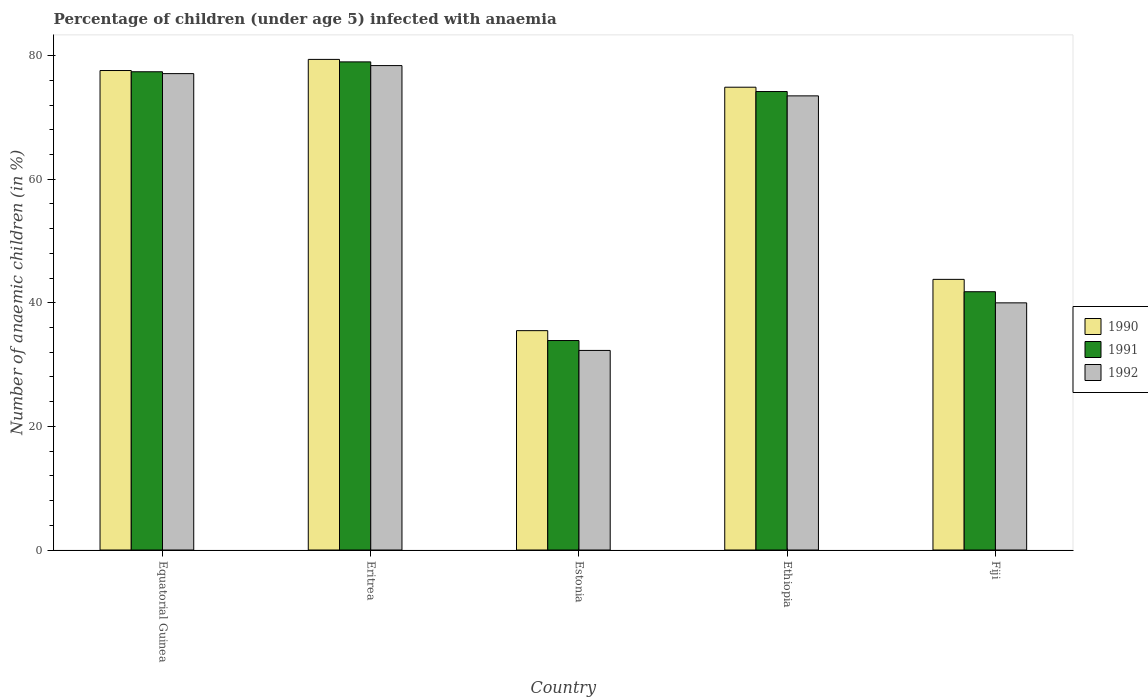How many different coloured bars are there?
Keep it short and to the point. 3. How many groups of bars are there?
Your answer should be compact. 5. How many bars are there on the 2nd tick from the left?
Give a very brief answer. 3. What is the label of the 2nd group of bars from the left?
Give a very brief answer. Eritrea. In how many cases, is the number of bars for a given country not equal to the number of legend labels?
Your answer should be compact. 0. What is the percentage of children infected with anaemia in in 1992 in Ethiopia?
Give a very brief answer. 73.5. Across all countries, what is the maximum percentage of children infected with anaemia in in 1991?
Offer a terse response. 79. Across all countries, what is the minimum percentage of children infected with anaemia in in 1991?
Your response must be concise. 33.9. In which country was the percentage of children infected with anaemia in in 1992 maximum?
Provide a succinct answer. Eritrea. In which country was the percentage of children infected with anaemia in in 1991 minimum?
Give a very brief answer. Estonia. What is the total percentage of children infected with anaemia in in 1990 in the graph?
Make the answer very short. 311.2. What is the difference between the percentage of children infected with anaemia in in 1991 in Equatorial Guinea and that in Ethiopia?
Provide a succinct answer. 3.2. What is the difference between the percentage of children infected with anaemia in in 1990 in Equatorial Guinea and the percentage of children infected with anaemia in in 1992 in Ethiopia?
Offer a terse response. 4.1. What is the average percentage of children infected with anaemia in in 1992 per country?
Ensure brevity in your answer.  60.26. What is the difference between the percentage of children infected with anaemia in of/in 1991 and percentage of children infected with anaemia in of/in 1990 in Fiji?
Provide a short and direct response. -2. In how many countries, is the percentage of children infected with anaemia in in 1991 greater than 60 %?
Provide a succinct answer. 3. What is the ratio of the percentage of children infected with anaemia in in 1990 in Equatorial Guinea to that in Estonia?
Your answer should be compact. 2.19. What is the difference between the highest and the second highest percentage of children infected with anaemia in in 1991?
Your response must be concise. -3.2. What is the difference between the highest and the lowest percentage of children infected with anaemia in in 1991?
Provide a short and direct response. 45.1. In how many countries, is the percentage of children infected with anaemia in in 1990 greater than the average percentage of children infected with anaemia in in 1990 taken over all countries?
Your response must be concise. 3. What does the 2nd bar from the left in Fiji represents?
Your answer should be compact. 1991. Is it the case that in every country, the sum of the percentage of children infected with anaemia in in 1990 and percentage of children infected with anaemia in in 1991 is greater than the percentage of children infected with anaemia in in 1992?
Your answer should be compact. Yes. How many bars are there?
Your answer should be compact. 15. What is the difference between two consecutive major ticks on the Y-axis?
Offer a terse response. 20. Does the graph contain grids?
Offer a terse response. No. How are the legend labels stacked?
Offer a very short reply. Vertical. What is the title of the graph?
Make the answer very short. Percentage of children (under age 5) infected with anaemia. Does "1970" appear as one of the legend labels in the graph?
Offer a terse response. No. What is the label or title of the X-axis?
Give a very brief answer. Country. What is the label or title of the Y-axis?
Keep it short and to the point. Number of anaemic children (in %). What is the Number of anaemic children (in %) of 1990 in Equatorial Guinea?
Your answer should be compact. 77.6. What is the Number of anaemic children (in %) in 1991 in Equatorial Guinea?
Ensure brevity in your answer.  77.4. What is the Number of anaemic children (in %) in 1992 in Equatorial Guinea?
Make the answer very short. 77.1. What is the Number of anaemic children (in %) of 1990 in Eritrea?
Offer a very short reply. 79.4. What is the Number of anaemic children (in %) of 1991 in Eritrea?
Your answer should be very brief. 79. What is the Number of anaemic children (in %) in 1992 in Eritrea?
Ensure brevity in your answer.  78.4. What is the Number of anaemic children (in %) of 1990 in Estonia?
Provide a succinct answer. 35.5. What is the Number of anaemic children (in %) of 1991 in Estonia?
Keep it short and to the point. 33.9. What is the Number of anaemic children (in %) of 1992 in Estonia?
Your response must be concise. 32.3. What is the Number of anaemic children (in %) in 1990 in Ethiopia?
Make the answer very short. 74.9. What is the Number of anaemic children (in %) in 1991 in Ethiopia?
Provide a short and direct response. 74.2. What is the Number of anaemic children (in %) of 1992 in Ethiopia?
Ensure brevity in your answer.  73.5. What is the Number of anaemic children (in %) of 1990 in Fiji?
Offer a terse response. 43.8. What is the Number of anaemic children (in %) in 1991 in Fiji?
Your answer should be very brief. 41.8. What is the Number of anaemic children (in %) of 1992 in Fiji?
Ensure brevity in your answer.  40. Across all countries, what is the maximum Number of anaemic children (in %) of 1990?
Your answer should be compact. 79.4. Across all countries, what is the maximum Number of anaemic children (in %) of 1991?
Provide a succinct answer. 79. Across all countries, what is the maximum Number of anaemic children (in %) of 1992?
Offer a terse response. 78.4. Across all countries, what is the minimum Number of anaemic children (in %) of 1990?
Make the answer very short. 35.5. Across all countries, what is the minimum Number of anaemic children (in %) in 1991?
Give a very brief answer. 33.9. Across all countries, what is the minimum Number of anaemic children (in %) in 1992?
Your response must be concise. 32.3. What is the total Number of anaemic children (in %) in 1990 in the graph?
Your answer should be very brief. 311.2. What is the total Number of anaemic children (in %) in 1991 in the graph?
Give a very brief answer. 306.3. What is the total Number of anaemic children (in %) of 1992 in the graph?
Your answer should be very brief. 301.3. What is the difference between the Number of anaemic children (in %) of 1990 in Equatorial Guinea and that in Eritrea?
Make the answer very short. -1.8. What is the difference between the Number of anaemic children (in %) of 1992 in Equatorial Guinea and that in Eritrea?
Provide a short and direct response. -1.3. What is the difference between the Number of anaemic children (in %) of 1990 in Equatorial Guinea and that in Estonia?
Make the answer very short. 42.1. What is the difference between the Number of anaemic children (in %) in 1991 in Equatorial Guinea and that in Estonia?
Give a very brief answer. 43.5. What is the difference between the Number of anaemic children (in %) of 1992 in Equatorial Guinea and that in Estonia?
Your answer should be compact. 44.8. What is the difference between the Number of anaemic children (in %) of 1992 in Equatorial Guinea and that in Ethiopia?
Make the answer very short. 3.6. What is the difference between the Number of anaemic children (in %) of 1990 in Equatorial Guinea and that in Fiji?
Your response must be concise. 33.8. What is the difference between the Number of anaemic children (in %) of 1991 in Equatorial Guinea and that in Fiji?
Your answer should be very brief. 35.6. What is the difference between the Number of anaemic children (in %) in 1992 in Equatorial Guinea and that in Fiji?
Offer a very short reply. 37.1. What is the difference between the Number of anaemic children (in %) in 1990 in Eritrea and that in Estonia?
Offer a very short reply. 43.9. What is the difference between the Number of anaemic children (in %) of 1991 in Eritrea and that in Estonia?
Offer a terse response. 45.1. What is the difference between the Number of anaemic children (in %) of 1992 in Eritrea and that in Estonia?
Offer a terse response. 46.1. What is the difference between the Number of anaemic children (in %) in 1990 in Eritrea and that in Ethiopia?
Give a very brief answer. 4.5. What is the difference between the Number of anaemic children (in %) in 1992 in Eritrea and that in Ethiopia?
Give a very brief answer. 4.9. What is the difference between the Number of anaemic children (in %) of 1990 in Eritrea and that in Fiji?
Provide a short and direct response. 35.6. What is the difference between the Number of anaemic children (in %) of 1991 in Eritrea and that in Fiji?
Your answer should be very brief. 37.2. What is the difference between the Number of anaemic children (in %) of 1992 in Eritrea and that in Fiji?
Give a very brief answer. 38.4. What is the difference between the Number of anaemic children (in %) in 1990 in Estonia and that in Ethiopia?
Provide a succinct answer. -39.4. What is the difference between the Number of anaemic children (in %) in 1991 in Estonia and that in Ethiopia?
Give a very brief answer. -40.3. What is the difference between the Number of anaemic children (in %) in 1992 in Estonia and that in Ethiopia?
Make the answer very short. -41.2. What is the difference between the Number of anaemic children (in %) in 1990 in Estonia and that in Fiji?
Your answer should be compact. -8.3. What is the difference between the Number of anaemic children (in %) in 1991 in Estonia and that in Fiji?
Make the answer very short. -7.9. What is the difference between the Number of anaemic children (in %) in 1992 in Estonia and that in Fiji?
Offer a terse response. -7.7. What is the difference between the Number of anaemic children (in %) in 1990 in Ethiopia and that in Fiji?
Your answer should be very brief. 31.1. What is the difference between the Number of anaemic children (in %) of 1991 in Ethiopia and that in Fiji?
Offer a terse response. 32.4. What is the difference between the Number of anaemic children (in %) of 1992 in Ethiopia and that in Fiji?
Keep it short and to the point. 33.5. What is the difference between the Number of anaemic children (in %) in 1990 in Equatorial Guinea and the Number of anaemic children (in %) in 1991 in Estonia?
Provide a succinct answer. 43.7. What is the difference between the Number of anaemic children (in %) of 1990 in Equatorial Guinea and the Number of anaemic children (in %) of 1992 in Estonia?
Your answer should be compact. 45.3. What is the difference between the Number of anaemic children (in %) of 1991 in Equatorial Guinea and the Number of anaemic children (in %) of 1992 in Estonia?
Ensure brevity in your answer.  45.1. What is the difference between the Number of anaemic children (in %) in 1990 in Equatorial Guinea and the Number of anaemic children (in %) in 1992 in Ethiopia?
Your answer should be compact. 4.1. What is the difference between the Number of anaemic children (in %) of 1990 in Equatorial Guinea and the Number of anaemic children (in %) of 1991 in Fiji?
Give a very brief answer. 35.8. What is the difference between the Number of anaemic children (in %) in 1990 in Equatorial Guinea and the Number of anaemic children (in %) in 1992 in Fiji?
Make the answer very short. 37.6. What is the difference between the Number of anaemic children (in %) in 1991 in Equatorial Guinea and the Number of anaemic children (in %) in 1992 in Fiji?
Ensure brevity in your answer.  37.4. What is the difference between the Number of anaemic children (in %) of 1990 in Eritrea and the Number of anaemic children (in %) of 1991 in Estonia?
Ensure brevity in your answer.  45.5. What is the difference between the Number of anaemic children (in %) in 1990 in Eritrea and the Number of anaemic children (in %) in 1992 in Estonia?
Offer a terse response. 47.1. What is the difference between the Number of anaemic children (in %) of 1991 in Eritrea and the Number of anaemic children (in %) of 1992 in Estonia?
Provide a succinct answer. 46.7. What is the difference between the Number of anaemic children (in %) in 1990 in Eritrea and the Number of anaemic children (in %) in 1992 in Ethiopia?
Your answer should be compact. 5.9. What is the difference between the Number of anaemic children (in %) in 1990 in Eritrea and the Number of anaemic children (in %) in 1991 in Fiji?
Your answer should be very brief. 37.6. What is the difference between the Number of anaemic children (in %) in 1990 in Eritrea and the Number of anaemic children (in %) in 1992 in Fiji?
Ensure brevity in your answer.  39.4. What is the difference between the Number of anaemic children (in %) in 1990 in Estonia and the Number of anaemic children (in %) in 1991 in Ethiopia?
Provide a succinct answer. -38.7. What is the difference between the Number of anaemic children (in %) in 1990 in Estonia and the Number of anaemic children (in %) in 1992 in Ethiopia?
Give a very brief answer. -38. What is the difference between the Number of anaemic children (in %) of 1991 in Estonia and the Number of anaemic children (in %) of 1992 in Ethiopia?
Your answer should be very brief. -39.6. What is the difference between the Number of anaemic children (in %) in 1990 in Estonia and the Number of anaemic children (in %) in 1991 in Fiji?
Your response must be concise. -6.3. What is the difference between the Number of anaemic children (in %) of 1991 in Estonia and the Number of anaemic children (in %) of 1992 in Fiji?
Ensure brevity in your answer.  -6.1. What is the difference between the Number of anaemic children (in %) of 1990 in Ethiopia and the Number of anaemic children (in %) of 1991 in Fiji?
Your response must be concise. 33.1. What is the difference between the Number of anaemic children (in %) in 1990 in Ethiopia and the Number of anaemic children (in %) in 1992 in Fiji?
Make the answer very short. 34.9. What is the difference between the Number of anaemic children (in %) of 1991 in Ethiopia and the Number of anaemic children (in %) of 1992 in Fiji?
Offer a terse response. 34.2. What is the average Number of anaemic children (in %) of 1990 per country?
Offer a terse response. 62.24. What is the average Number of anaemic children (in %) in 1991 per country?
Provide a succinct answer. 61.26. What is the average Number of anaemic children (in %) of 1992 per country?
Make the answer very short. 60.26. What is the difference between the Number of anaemic children (in %) of 1990 and Number of anaemic children (in %) of 1991 in Equatorial Guinea?
Your response must be concise. 0.2. What is the difference between the Number of anaemic children (in %) in 1990 and Number of anaemic children (in %) in 1992 in Equatorial Guinea?
Give a very brief answer. 0.5. What is the difference between the Number of anaemic children (in %) of 1991 and Number of anaemic children (in %) of 1992 in Equatorial Guinea?
Provide a succinct answer. 0.3. What is the difference between the Number of anaemic children (in %) of 1990 and Number of anaemic children (in %) of 1991 in Eritrea?
Your answer should be very brief. 0.4. What is the difference between the Number of anaemic children (in %) in 1990 and Number of anaemic children (in %) in 1992 in Eritrea?
Your answer should be compact. 1. What is the difference between the Number of anaemic children (in %) of 1990 and Number of anaemic children (in %) of 1991 in Estonia?
Give a very brief answer. 1.6. What is the difference between the Number of anaemic children (in %) of 1990 and Number of anaemic children (in %) of 1991 in Ethiopia?
Your answer should be compact. 0.7. What is the difference between the Number of anaemic children (in %) of 1990 and Number of anaemic children (in %) of 1992 in Ethiopia?
Give a very brief answer. 1.4. What is the difference between the Number of anaemic children (in %) in 1990 and Number of anaemic children (in %) in 1991 in Fiji?
Give a very brief answer. 2. What is the difference between the Number of anaemic children (in %) in 1990 and Number of anaemic children (in %) in 1992 in Fiji?
Provide a short and direct response. 3.8. What is the difference between the Number of anaemic children (in %) of 1991 and Number of anaemic children (in %) of 1992 in Fiji?
Provide a succinct answer. 1.8. What is the ratio of the Number of anaemic children (in %) of 1990 in Equatorial Guinea to that in Eritrea?
Your answer should be compact. 0.98. What is the ratio of the Number of anaemic children (in %) of 1991 in Equatorial Guinea to that in Eritrea?
Provide a succinct answer. 0.98. What is the ratio of the Number of anaemic children (in %) of 1992 in Equatorial Guinea to that in Eritrea?
Offer a very short reply. 0.98. What is the ratio of the Number of anaemic children (in %) of 1990 in Equatorial Guinea to that in Estonia?
Give a very brief answer. 2.19. What is the ratio of the Number of anaemic children (in %) in 1991 in Equatorial Guinea to that in Estonia?
Offer a very short reply. 2.28. What is the ratio of the Number of anaemic children (in %) of 1992 in Equatorial Guinea to that in Estonia?
Your answer should be very brief. 2.39. What is the ratio of the Number of anaemic children (in %) of 1990 in Equatorial Guinea to that in Ethiopia?
Ensure brevity in your answer.  1.04. What is the ratio of the Number of anaemic children (in %) in 1991 in Equatorial Guinea to that in Ethiopia?
Offer a very short reply. 1.04. What is the ratio of the Number of anaemic children (in %) in 1992 in Equatorial Guinea to that in Ethiopia?
Make the answer very short. 1.05. What is the ratio of the Number of anaemic children (in %) of 1990 in Equatorial Guinea to that in Fiji?
Ensure brevity in your answer.  1.77. What is the ratio of the Number of anaemic children (in %) in 1991 in Equatorial Guinea to that in Fiji?
Ensure brevity in your answer.  1.85. What is the ratio of the Number of anaemic children (in %) in 1992 in Equatorial Guinea to that in Fiji?
Make the answer very short. 1.93. What is the ratio of the Number of anaemic children (in %) in 1990 in Eritrea to that in Estonia?
Your answer should be very brief. 2.24. What is the ratio of the Number of anaemic children (in %) of 1991 in Eritrea to that in Estonia?
Offer a very short reply. 2.33. What is the ratio of the Number of anaemic children (in %) of 1992 in Eritrea to that in Estonia?
Ensure brevity in your answer.  2.43. What is the ratio of the Number of anaemic children (in %) of 1990 in Eritrea to that in Ethiopia?
Your answer should be compact. 1.06. What is the ratio of the Number of anaemic children (in %) in 1991 in Eritrea to that in Ethiopia?
Provide a succinct answer. 1.06. What is the ratio of the Number of anaemic children (in %) in 1992 in Eritrea to that in Ethiopia?
Your answer should be very brief. 1.07. What is the ratio of the Number of anaemic children (in %) of 1990 in Eritrea to that in Fiji?
Keep it short and to the point. 1.81. What is the ratio of the Number of anaemic children (in %) in 1991 in Eritrea to that in Fiji?
Your answer should be very brief. 1.89. What is the ratio of the Number of anaemic children (in %) in 1992 in Eritrea to that in Fiji?
Keep it short and to the point. 1.96. What is the ratio of the Number of anaemic children (in %) in 1990 in Estonia to that in Ethiopia?
Provide a succinct answer. 0.47. What is the ratio of the Number of anaemic children (in %) of 1991 in Estonia to that in Ethiopia?
Provide a short and direct response. 0.46. What is the ratio of the Number of anaemic children (in %) of 1992 in Estonia to that in Ethiopia?
Make the answer very short. 0.44. What is the ratio of the Number of anaemic children (in %) in 1990 in Estonia to that in Fiji?
Offer a very short reply. 0.81. What is the ratio of the Number of anaemic children (in %) in 1991 in Estonia to that in Fiji?
Your response must be concise. 0.81. What is the ratio of the Number of anaemic children (in %) of 1992 in Estonia to that in Fiji?
Offer a very short reply. 0.81. What is the ratio of the Number of anaemic children (in %) in 1990 in Ethiopia to that in Fiji?
Your answer should be very brief. 1.71. What is the ratio of the Number of anaemic children (in %) of 1991 in Ethiopia to that in Fiji?
Offer a very short reply. 1.78. What is the ratio of the Number of anaemic children (in %) in 1992 in Ethiopia to that in Fiji?
Keep it short and to the point. 1.84. What is the difference between the highest and the second highest Number of anaemic children (in %) of 1990?
Provide a succinct answer. 1.8. What is the difference between the highest and the lowest Number of anaemic children (in %) in 1990?
Offer a terse response. 43.9. What is the difference between the highest and the lowest Number of anaemic children (in %) in 1991?
Your answer should be very brief. 45.1. What is the difference between the highest and the lowest Number of anaemic children (in %) of 1992?
Provide a short and direct response. 46.1. 